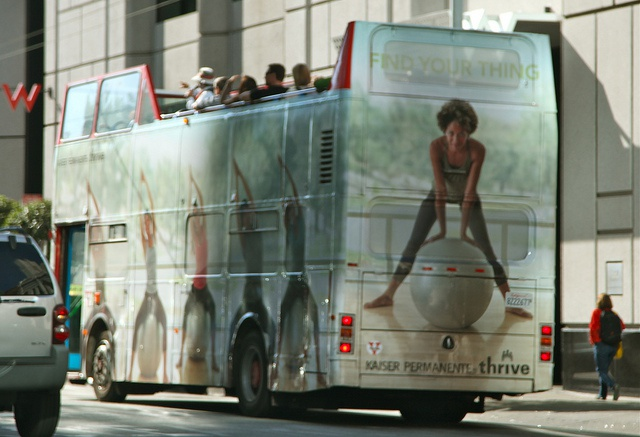Describe the objects in this image and their specific colors. I can see bus in gray, darkgray, lightgray, and black tones, car in gray, black, and darkgray tones, people in gray, black, and maroon tones, people in gray, darkgray, lightgray, tan, and beige tones, and people in gray, black, and maroon tones in this image. 